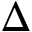Convert formula to latex. <formula><loc_0><loc_0><loc_500><loc_500>\Delta</formula> 